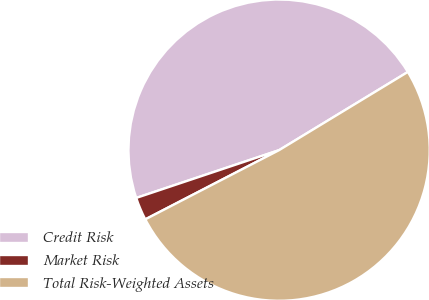Convert chart to OTSL. <chart><loc_0><loc_0><loc_500><loc_500><pie_chart><fcel>Credit Risk<fcel>Market Risk<fcel>Total Risk-Weighted Assets<nl><fcel>46.45%<fcel>2.46%<fcel>51.09%<nl></chart> 